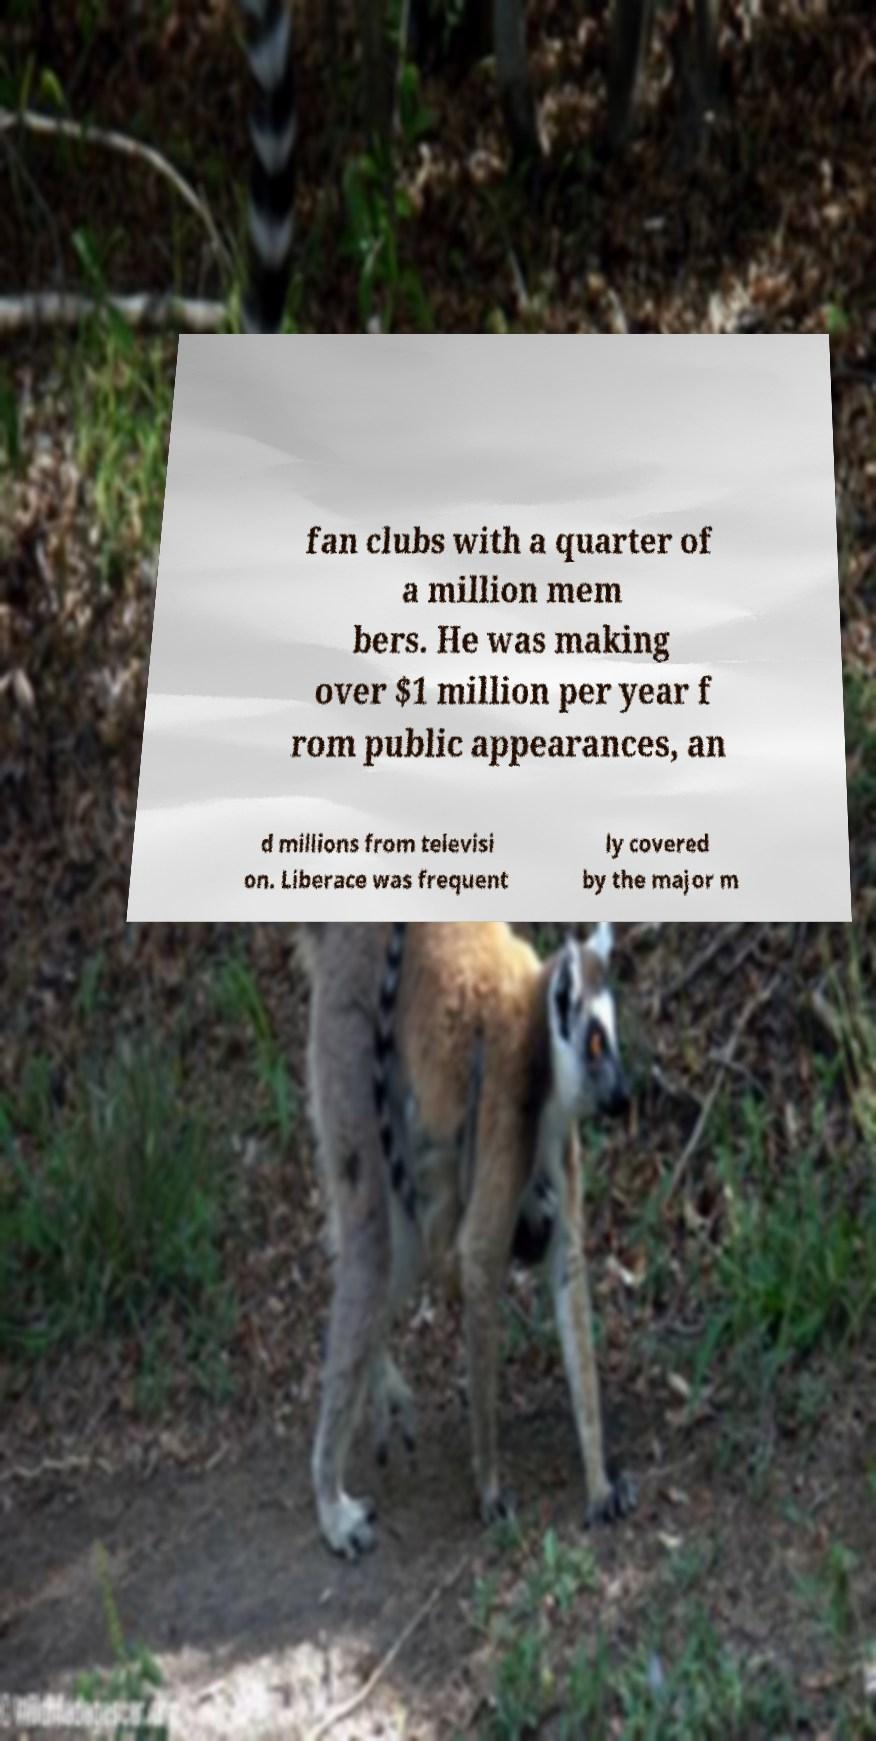What messages or text are displayed in this image? I need them in a readable, typed format. fan clubs with a quarter of a million mem bers. He was making over $1 million per year f rom public appearances, an d millions from televisi on. Liberace was frequent ly covered by the major m 